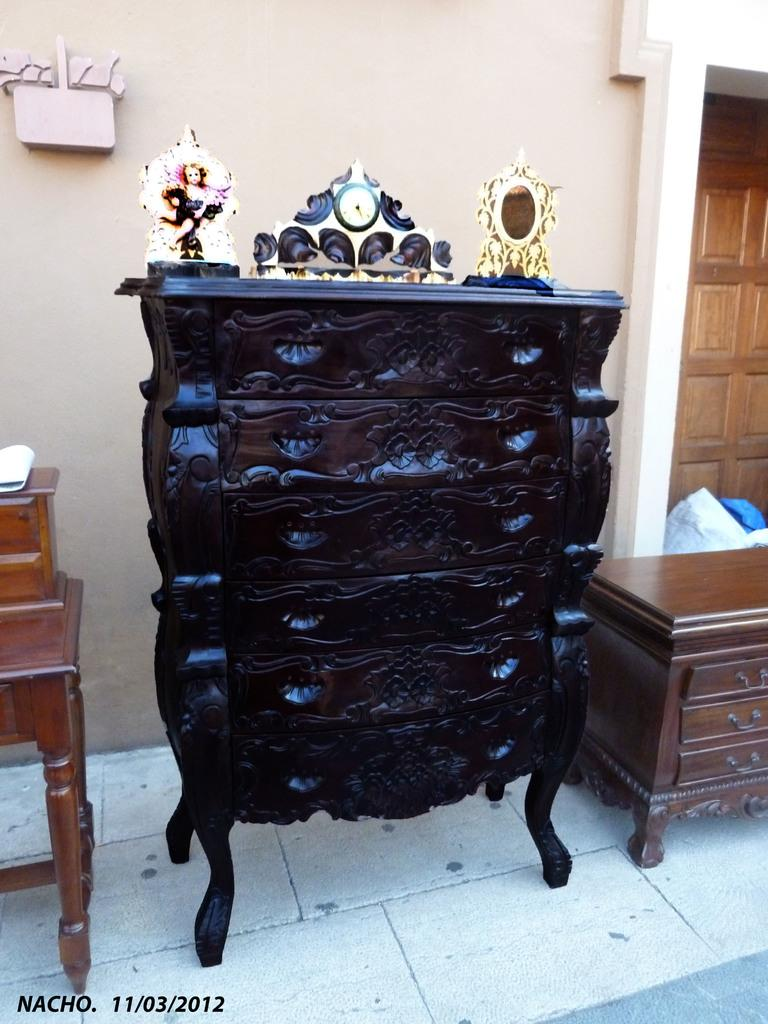What type of objects can be seen in the image? There is furniture in the image. Can you describe the table in the image? There is a table on the floor in the image. What is visible in the background of the image? There is a wall visible in the background of the image. What architectural feature is present in the image? There is a door in the image. What is covering something in the image? There is a cover in the image. How many beggars are visible in the image? There are no beggars present in the image. What type of unit is being measured in the image? There is no unit being measured in the image. What type of animal is shown with a tail in the image? There is no animal with a tail present in the image. 